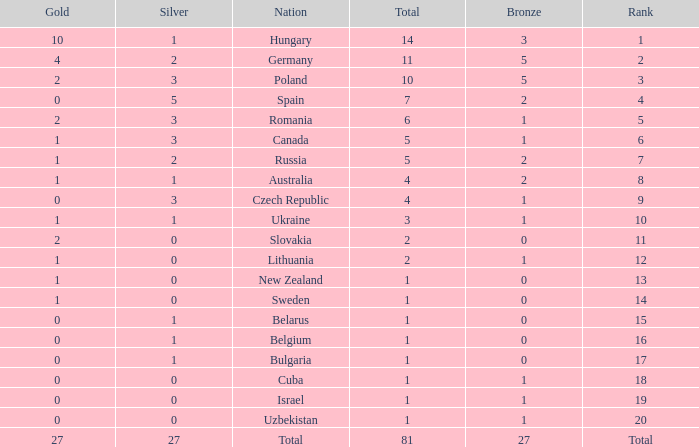Which Rank has a Bronze of 1, and a Nation of lithuania? 12.0. 